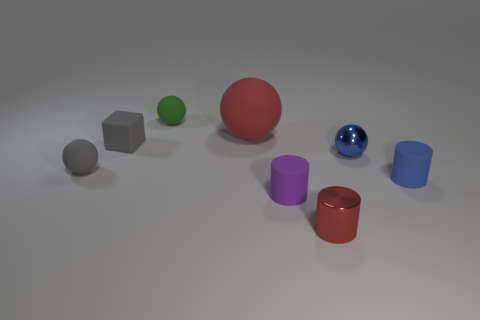Describe the lighting and shadow effects observed in the scene. The lighting in the scene comes from the upper left, as indicated by the shadows cast to the lower right of the objects. This creates a soft, diffused light effect, with the shadow lengths suggesting a light source that is not too far above the objects. The shadows are slightly blurred at the edges, which contributes to the perception of a gentle, ambient light rather than harsh direct sunlight. 